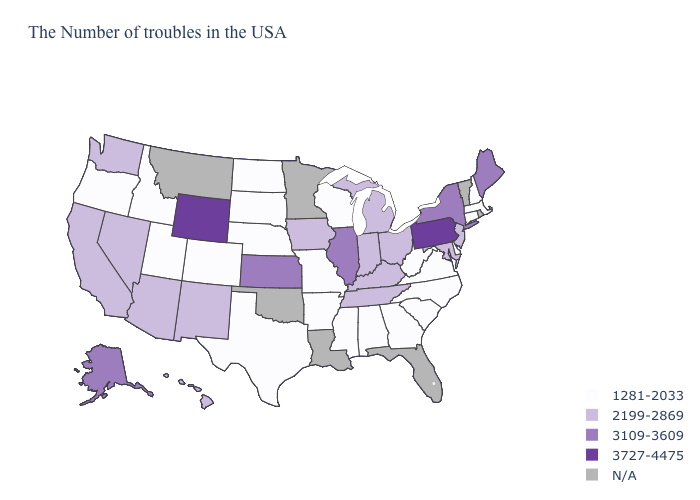What is the highest value in the USA?
Keep it brief. 3727-4475. Which states have the highest value in the USA?
Concise answer only. Pennsylvania, Wyoming. What is the highest value in the USA?
Concise answer only. 3727-4475. Among the states that border Colorado , does Wyoming have the highest value?
Answer briefly. Yes. What is the lowest value in the South?
Answer briefly. 1281-2033. What is the value of Idaho?
Write a very short answer. 1281-2033. What is the highest value in the South ?
Write a very short answer. 2199-2869. Which states have the highest value in the USA?
Keep it brief. Pennsylvania, Wyoming. Among the states that border Georgia , which have the highest value?
Quick response, please. Tennessee. How many symbols are there in the legend?
Answer briefly. 5. What is the highest value in the USA?
Answer briefly. 3727-4475. Does Colorado have the lowest value in the West?
Give a very brief answer. Yes. Which states have the lowest value in the South?
Answer briefly. Delaware, Virginia, North Carolina, South Carolina, West Virginia, Georgia, Alabama, Mississippi, Arkansas, Texas. Name the states that have a value in the range 1281-2033?
Short answer required. Massachusetts, New Hampshire, Connecticut, Delaware, Virginia, North Carolina, South Carolina, West Virginia, Georgia, Alabama, Wisconsin, Mississippi, Missouri, Arkansas, Nebraska, Texas, South Dakota, North Dakota, Colorado, Utah, Idaho, Oregon. 